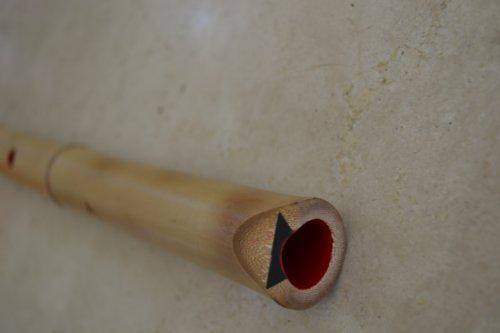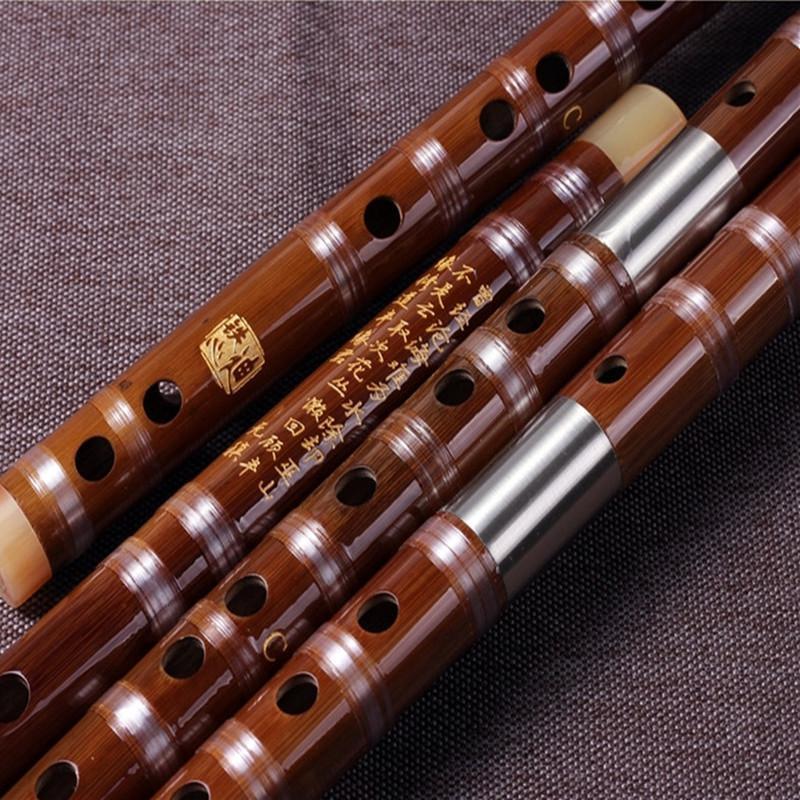The first image is the image on the left, the second image is the image on the right. Assess this claim about the two images: "Each image contains exactly one bamboo flute, and the left image shows a flute displayed diagonally and overlapping a folded band of cloth.". Correct or not? Answer yes or no. No. The first image is the image on the left, the second image is the image on the right. Evaluate the accuracy of this statement regarding the images: "The left and right image contains the same number of flutes.". Is it true? Answer yes or no. No. 